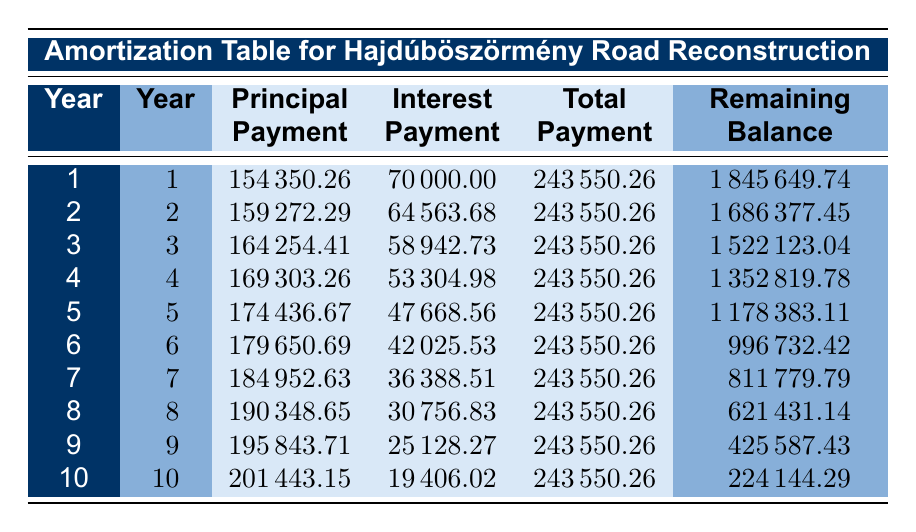What is the total amount borrowed for the Hajdúböszörmény Road Reconstruction project? The table states that the loan amount for this project is 2000000.
Answer: 2000000 In which year is the principal payment the highest for Hajdúböszörmény Road Reconstruction? By reviewing the principal payments, the highest value is in year 10 at 201443.15.
Answer: Year 10 What is the total payment made in year 5 for the Hajdúböszörmény Road Reconstruction? The total payment column for year 5 shows that the total payment is 243550.26.
Answer: 243550.26 What is the remaining balance after year 3 in the Hajdúböszörmény Road Reconstruction project? The table indicates that after year 3, the remaining balance is 1522123.04.
Answer: 1522123.04 Is the interest payment in year 2 higher than in year 1 for the Hajdúböszörmény Road Reconstruction? Comparing the interest payments, year 2 has 64563.68 and year 1 has 70000, therefore year 1's interest payment is higher.
Answer: No What is the average principal payment over the 10 years for the Hajdúböszörmény Road Reconstruction project? To find the average, sum all principal payments: (154350.26 + 159272.29 + 164254.41 + 169303.26 + 174436.67 + 179650.69 + 184952.63 + 190348.65 + 195843.71 + 201443.15) = 1821534.77; then divide by 10. The average principal payment is 182153.48.
Answer: 182153.48 Which year has the lowest remaining balance, and what is that balance? The remaining balances decrease over time; by checking each year's value, the lowest remaining balance is 224144.29 in year 10.
Answer: 224144.29 How much was paid in interest over the entire term for the Hajdúböszörmény Road Reconstruction project? To find total interest, sum all interest payments from years 1 to 10: (70000 + 64563.68 + 58942.73 + 53304.98 + 47668.56 + 42025.53 + 36388.51 + 30756.83 + 25128.27 + 19406.02) =  443594.58.
Answer: 443594.58 Was more principal paid in year 4 compared to year 3? Checking both years, the principal payment in year 4 is 169303.26 while in year 3 it is 164254.41; hence, year 4 had more principal paid.
Answer: Yes 